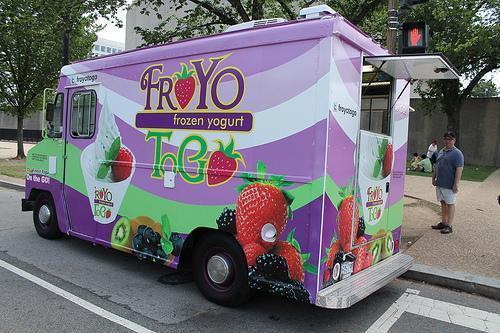How many trucks are in the picture?
Give a very brief answer. 1. 